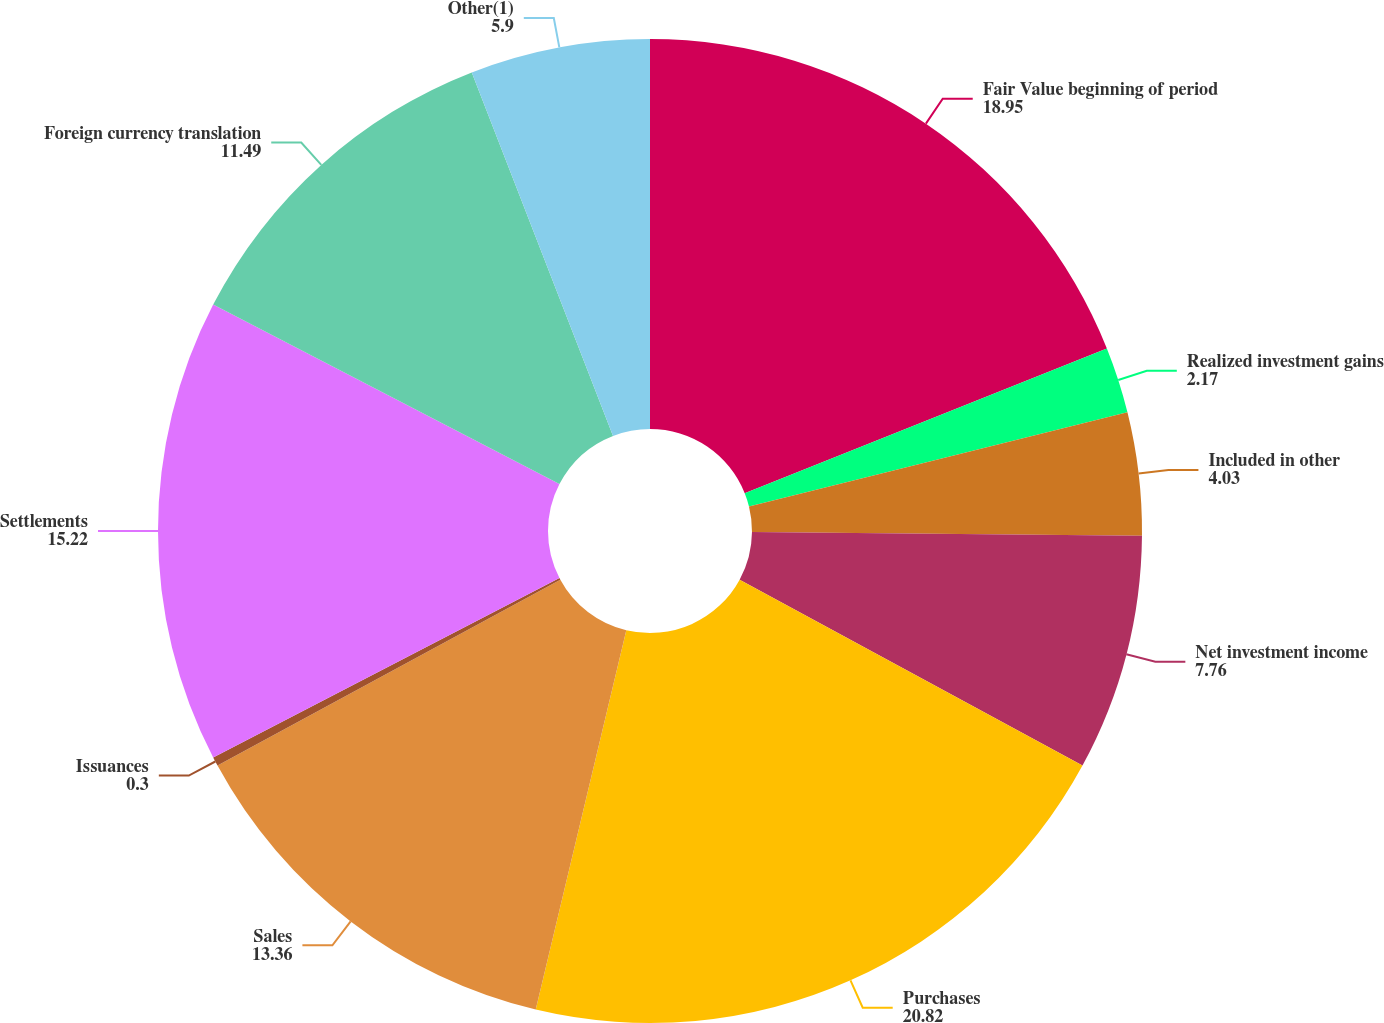Convert chart to OTSL. <chart><loc_0><loc_0><loc_500><loc_500><pie_chart><fcel>Fair Value beginning of period<fcel>Realized investment gains<fcel>Included in other<fcel>Net investment income<fcel>Purchases<fcel>Sales<fcel>Issuances<fcel>Settlements<fcel>Foreign currency translation<fcel>Other(1)<nl><fcel>18.95%<fcel>2.17%<fcel>4.03%<fcel>7.76%<fcel>20.82%<fcel>13.36%<fcel>0.3%<fcel>15.22%<fcel>11.49%<fcel>5.9%<nl></chart> 